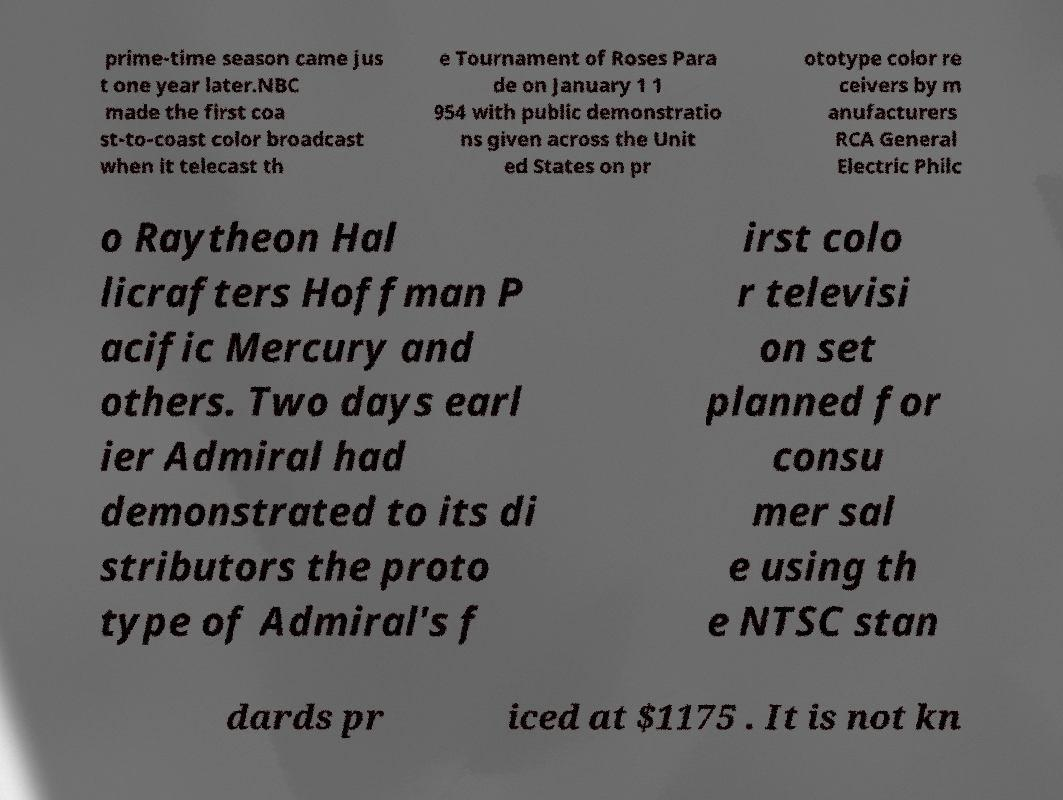Please identify and transcribe the text found in this image. prime-time season came jus t one year later.NBC made the first coa st-to-coast color broadcast when it telecast th e Tournament of Roses Para de on January 1 1 954 with public demonstratio ns given across the Unit ed States on pr ototype color re ceivers by m anufacturers RCA General Electric Philc o Raytheon Hal licrafters Hoffman P acific Mercury and others. Two days earl ier Admiral had demonstrated to its di stributors the proto type of Admiral's f irst colo r televisi on set planned for consu mer sal e using th e NTSC stan dards pr iced at $1175 . It is not kn 